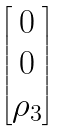<formula> <loc_0><loc_0><loc_500><loc_500>\begin{bmatrix} 0 \\ 0 \\ \rho _ { 3 } \end{bmatrix}</formula> 